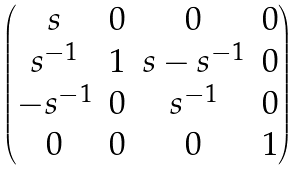Convert formula to latex. <formula><loc_0><loc_0><loc_500><loc_500>\begin{pmatrix} s & 0 & 0 & 0 \\ s ^ { - 1 } & 1 & s - s ^ { - 1 } & 0 \\ - s ^ { - 1 } & 0 & s ^ { - 1 } & 0 \\ 0 & 0 & 0 & 1 \end{pmatrix}</formula> 